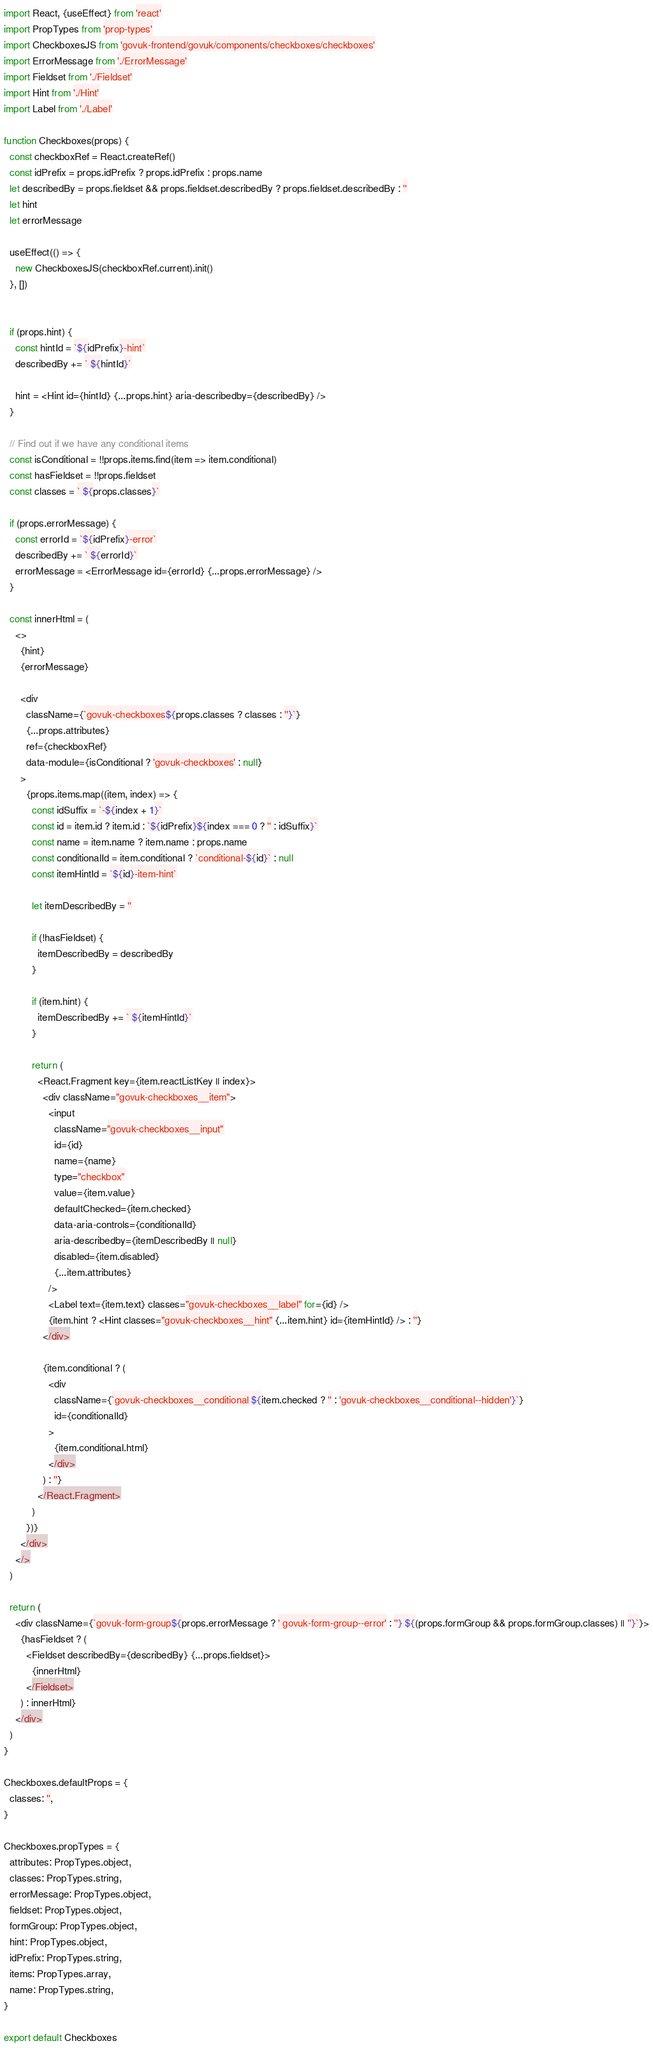Convert code to text. <code><loc_0><loc_0><loc_500><loc_500><_JavaScript_>import React, {useEffect} from 'react'
import PropTypes from 'prop-types'
import CheckboxesJS from 'govuk-frontend/govuk/components/checkboxes/checkboxes'
import ErrorMessage from './ErrorMessage'
import Fieldset from './Fieldset'
import Hint from './Hint'
import Label from './Label'

function Checkboxes(props) {
  const checkboxRef = React.createRef()
  const idPrefix = props.idPrefix ? props.idPrefix : props.name
  let describedBy = props.fieldset && props.fieldset.describedBy ? props.fieldset.describedBy : ''
  let hint
  let errorMessage

  useEffect(() => {
    new CheckboxesJS(checkboxRef.current).init()
  }, [])


  if (props.hint) {
    const hintId = `${idPrefix}-hint`
    describedBy += ` ${hintId}`

    hint = <Hint id={hintId} {...props.hint} aria-describedby={describedBy} />
  }

  // Find out if we have any conditional items
  const isConditional = !!props.items.find(item => item.conditional)
  const hasFieldset = !!props.fieldset
  const classes = ` ${props.classes}`

  if (props.errorMessage) {
    const errorId = `${idPrefix}-error`
    describedBy += ` ${errorId}`
    errorMessage = <ErrorMessage id={errorId} {...props.errorMessage} />
  }

  const innerHtml = (
    <>
      {hint}
      {errorMessage}

      <div
        className={`govuk-checkboxes${props.classes ? classes : ''}`}
        {...props.attributes}
        ref={checkboxRef}
        data-module={isConditional ? 'govuk-checkboxes' : null}
      >
        {props.items.map((item, index) => {
          const idSuffix = `-${index + 1}`
          const id = item.id ? item.id : `${idPrefix}${index === 0 ? '' : idSuffix}`
          const name = item.name ? item.name : props.name
          const conditionalId = item.conditional ? `conditional-${id}` : null
          const itemHintId = `${id}-item-hint`

          let itemDescribedBy = ''

          if (!hasFieldset) {
            itemDescribedBy = describedBy
          }

          if (item.hint) {
            itemDescribedBy += ` ${itemHintId}`
          }

          return (
            <React.Fragment key={item.reactListKey || index}>
              <div className="govuk-checkboxes__item">
                <input
                  className="govuk-checkboxes__input"
                  id={id}
                  name={name}
                  type="checkbox"
                  value={item.value}
                  defaultChecked={item.checked}
                  data-aria-controls={conditionalId}
                  aria-describedby={itemDescribedBy || null}
                  disabled={item.disabled}
                  {...item.attributes}
                />
                <Label text={item.text} classes="govuk-checkboxes__label" for={id} />
                {item.hint ? <Hint classes="govuk-checkboxes__hint" {...item.hint} id={itemHintId} /> : ''}
              </div>

              {item.conditional ? (
                <div
                  className={`govuk-checkboxes__conditional ${item.checked ? '' : 'govuk-checkboxes__conditional--hidden'}`}
                  id={conditionalId}
                >
                  {item.conditional.html}
                </div>
              ) : ''}
            </React.Fragment>
          )
        })}
      </div>
    </>
  )

  return (
    <div className={`govuk-form-group${props.errorMessage ? ' govuk-form-group--error' : ''} ${(props.formGroup && props.formGroup.classes) || ''}`}>
      {hasFieldset ? (
        <Fieldset describedBy={describedBy} {...props.fieldset}>
          {innerHtml}
        </Fieldset>
      ) : innerHtml}
    </div>
  )
}

Checkboxes.defaultProps = {
  classes: '',
}

Checkboxes.propTypes = {
  attributes: PropTypes.object,
  classes: PropTypes.string,
  errorMessage: PropTypes.object,
  fieldset: PropTypes.object,
  formGroup: PropTypes.object,
  hint: PropTypes.object,
  idPrefix: PropTypes.string,
  items: PropTypes.array,
  name: PropTypes.string,
}

export default Checkboxes
</code> 